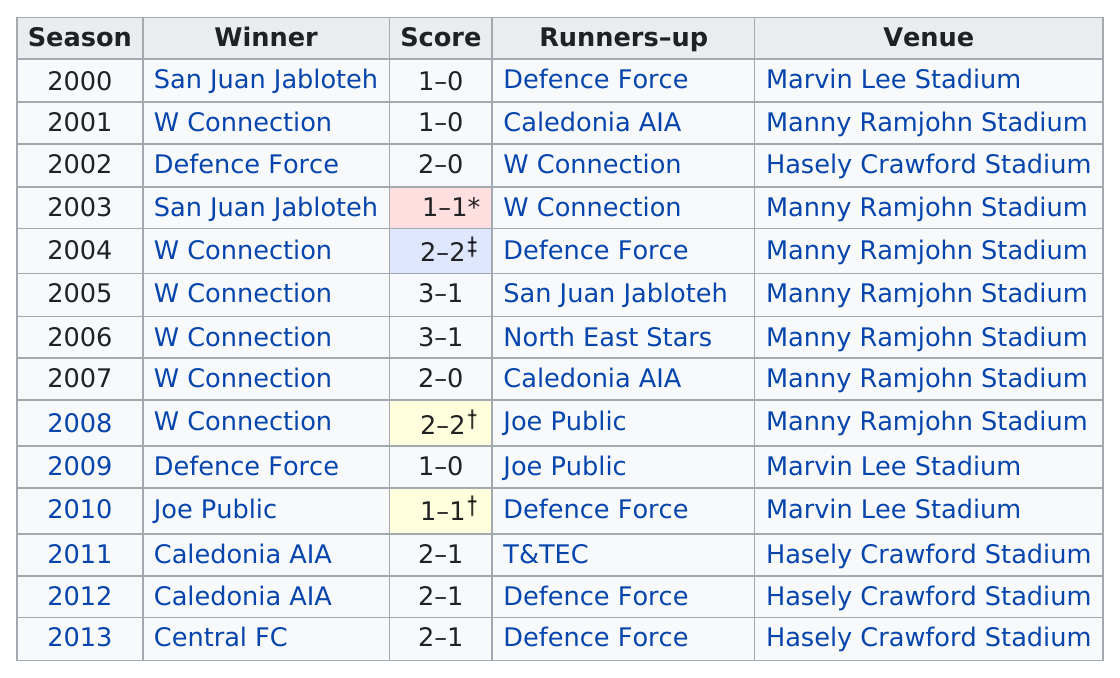Outline some significant characteristics in this image. W Connection has won the most league cups. The number of games played at Manny Ramjohn Stadium is 4, while the number of games played at Marvin Lee Stadium is also 4. W Connection is the team that won the Trinidad and Tobago League Cup the most times between 2000 and 2012. The result was: "W connection was the winner 6 times. W Connection scored more points than San Juan Jabloteh in 2005 by a margin of 2 points. 